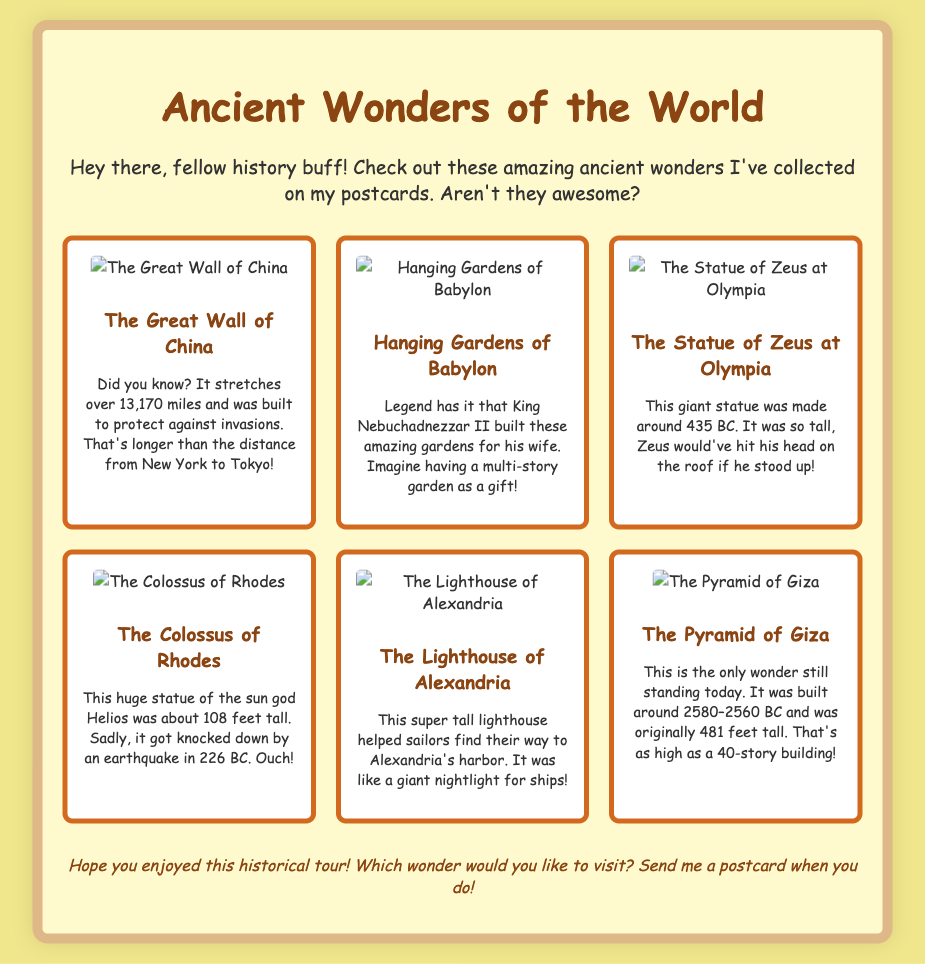What is the length of the Great Wall of China? The length of the Great Wall of China is stated in the document as over 13,170 miles.
Answer: over 13,170 miles Who built the Hanging Gardens of Babylon? The document indicates that King Nebuchadnezzar II built the Hanging Gardens for his wife.
Answer: King Nebuchadnezzar II What year was the Statue of Zeus at Olympia made? The document provides that the Statue of Zeus was made around 435 BC.
Answer: around 435 BC How tall was the Colossus of Rhodes? The document mentions that the Colossus of Rhodes was about 108 feet tall.
Answer: about 108 feet Which wonder is the only one still standing today? The document states that the Pyramid of Giza is the only wonder still standing today.
Answer: Pyramid of Giza What was the purpose of the Lighthouse of Alexandria? According to the document, it helped sailors find their way to Alexandria's harbor.
Answer: helped sailors How tall was the Pyramid of Giza originally? The document notes that the Pyramid of Giza was originally 481 feet tall.
Answer: 481 feet What did the Colossus of Rhodes represent? The document specifies that the Colossus represented the sun god Helios.
Answer: sun god Helios How long did the Great Wall of China protect against invasions? The document does not specify a duration, but it implies extensive use against invasions.
Answer: extensive use 